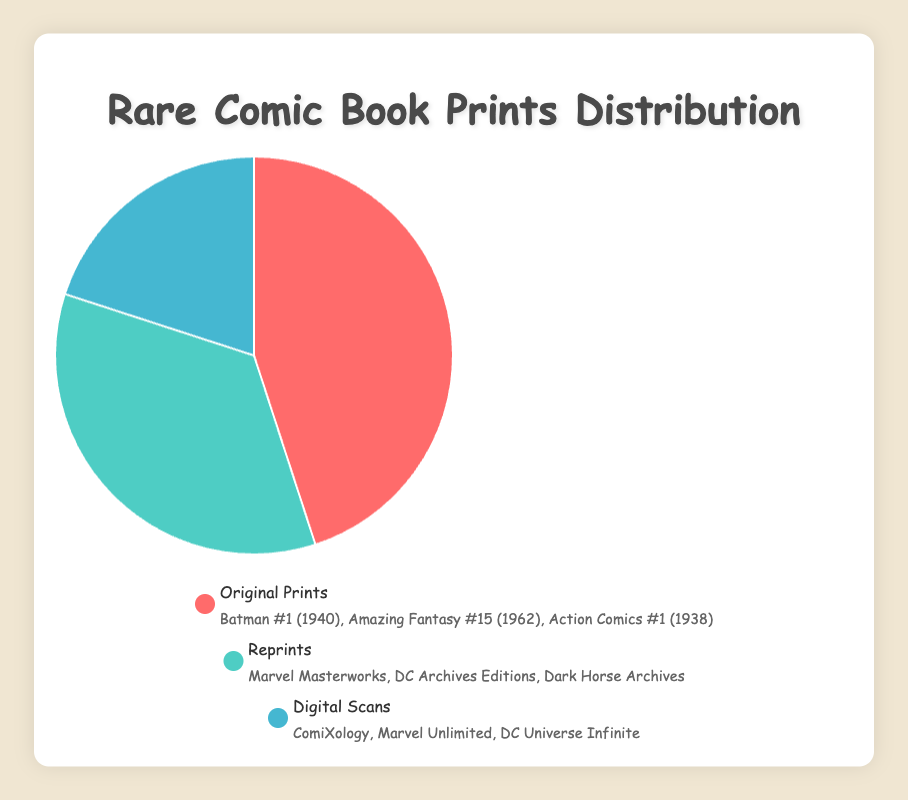What percentage of Rare Comic Book Prints are Reprints? The pie chart shows the distribution of different types of rare comic book prints, with Reprints occupying 35%.
Answer: 35% Which medium has the smallest percentage of Rare Comic Book Prints? By looking at the pie chart, the smallest section represents Digital Scans, which is 20%.
Answer: Digital Scans How much larger, in percentage points, are Original Prints compared to Digital Scans? Original Prints are at 45%, and Digital Scans are at 20%. The difference is 45% - 20% = 25 percentage points.
Answer: 25 percentage points What is the combined percentage of Reprints and Digital Scans? Adding the percentages of Reprints (35%) and Digital Scans (20%) gives 35% + 20% = 55%.
Answer: 55% Which color represents Reprints in the pie chart? The color representing Reprints is light green. This can be inferred from the legend which indicates light green for Reprints.
Answer: light green What is the dominant medium of Rare Comic Book Prints? The pie chart shows that Original Prints hold the highest percentage of 45%, making it the dominant medium.
Answer: Original Prints Are the combined percentages of Reprints and Digital Scans greater than Original Prints? The combined percentage of Reprints and Digital Scans is 55% (35% + 20%). Since Original Prints account for 45%, 55% is greater than 45%.
Answer: Yes Name a few entities listed under Original Prints. From the legend, entities listed under Original Prints include Batman #1 (1940), Amazing Fantasy #15 (1962), and Action Comics #1 (1938).
Answer: Batman #1 (1940); Amazing Fantasy #15 (1962); Action Comics #1 (1938) Which medium of Rare Comic Book Prints occupies more than one-third of the total distribution? Since 33.33% is one-third of the total distribution, Original Prints (45%) and Reprints (35%) both exceed one-third.
Answer: Original Prints; Reprints How does the percentage of Reprints compare to that of Digital Scans? Reprints occupy 35% of the distribution, whereas Digital Scans occupy 20%. Therefore, Reprints represent a higher percentage than Digital Scans.
Answer: 35% vs. 20% 